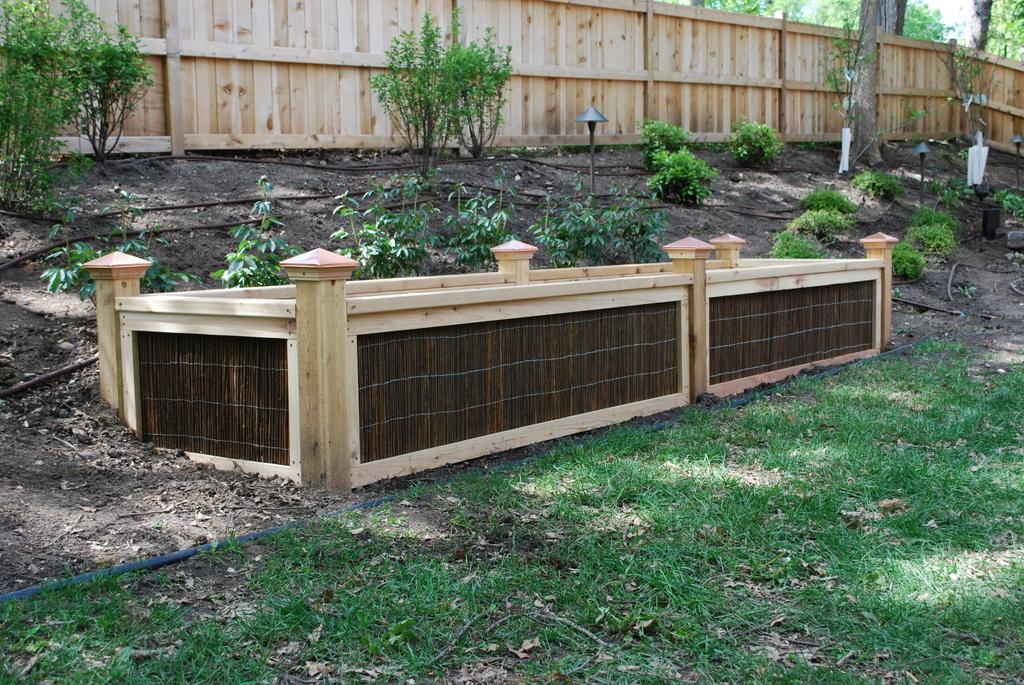What type of surface is on the ground in the image? There is grass on the ground in the image. What other objects can be seen on the ground? There is a pipe, plants, and a wooden block on the ground. What is visible in the background of the image? There is wooden fencing and trees in the background. What type of leather material is used to make the rule in the image? There is no rule or leather material present in the image. 